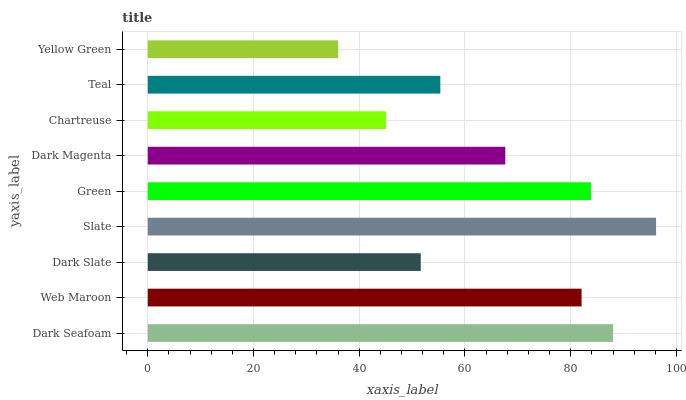Is Yellow Green the minimum?
Answer yes or no. Yes. Is Slate the maximum?
Answer yes or no. Yes. Is Web Maroon the minimum?
Answer yes or no. No. Is Web Maroon the maximum?
Answer yes or no. No. Is Dark Seafoam greater than Web Maroon?
Answer yes or no. Yes. Is Web Maroon less than Dark Seafoam?
Answer yes or no. Yes. Is Web Maroon greater than Dark Seafoam?
Answer yes or no. No. Is Dark Seafoam less than Web Maroon?
Answer yes or no. No. Is Dark Magenta the high median?
Answer yes or no. Yes. Is Dark Magenta the low median?
Answer yes or no. Yes. Is Slate the high median?
Answer yes or no. No. Is Dark Seafoam the low median?
Answer yes or no. No. 